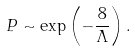<formula> <loc_0><loc_0><loc_500><loc_500>P \sim \exp \left ( - \frac { 8 } { \Lambda } \right ) .</formula> 